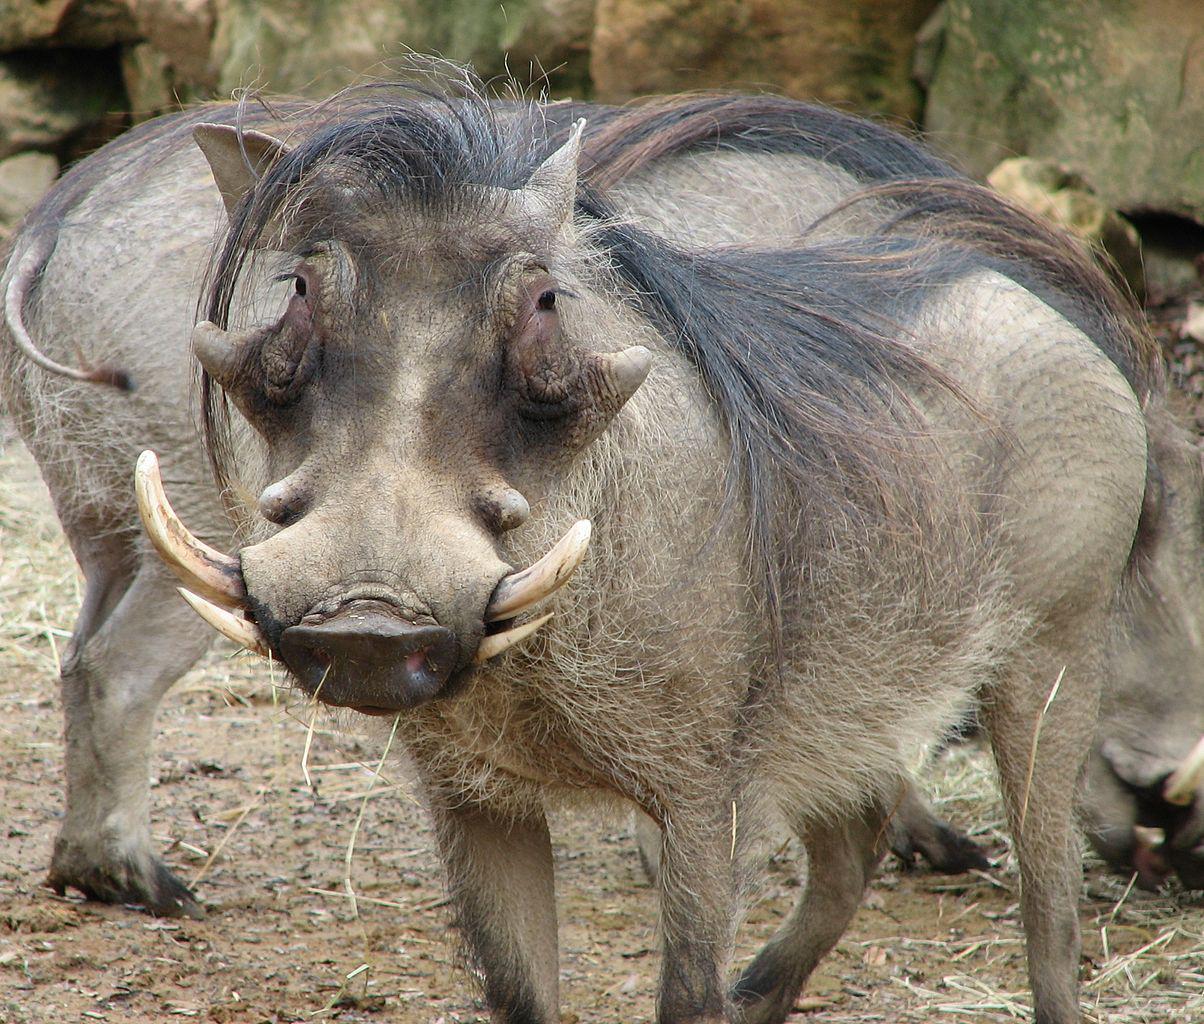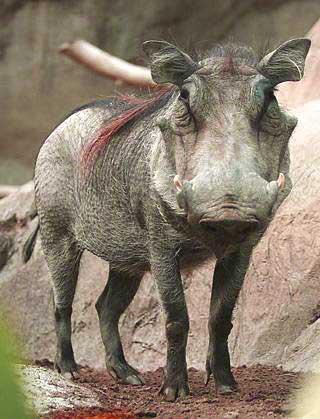The first image is the image on the left, the second image is the image on the right. Considering the images on both sides, is "Each image includes a warthog with its head facing the camera." valid? Answer yes or no. Yes. The first image is the image on the left, the second image is the image on the right. For the images shown, is this caption "There are two hogs in total." true? Answer yes or no. No. 